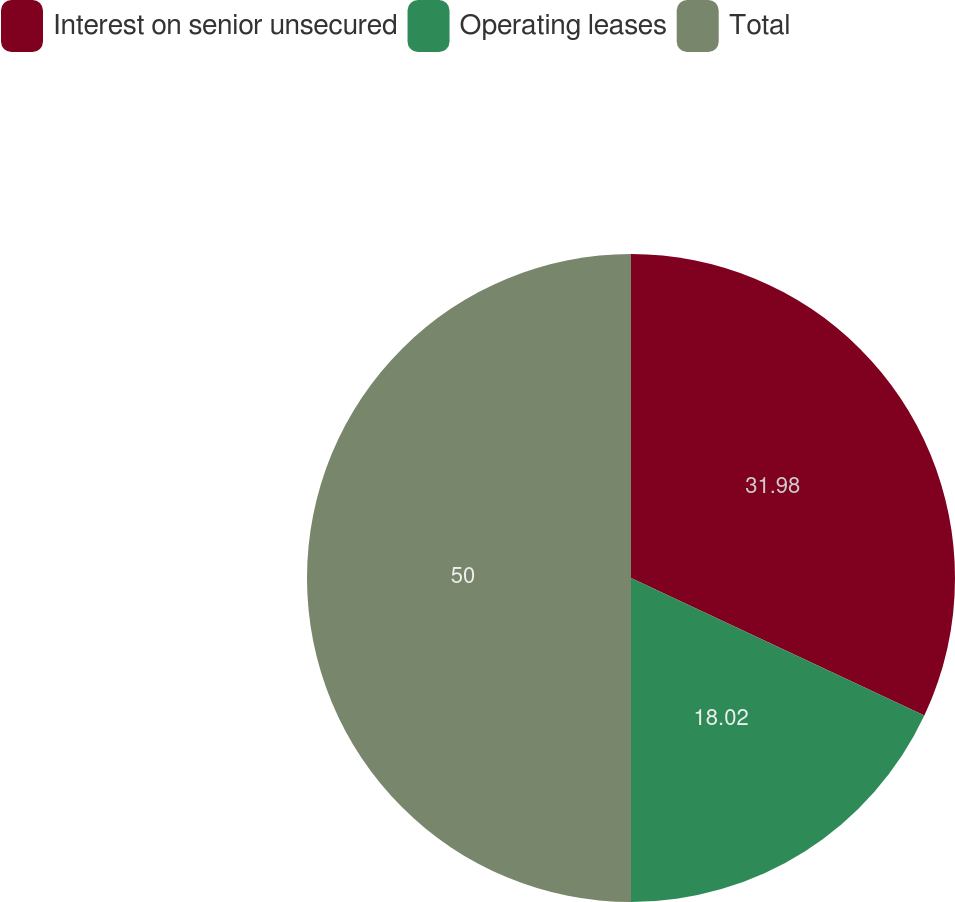Convert chart to OTSL. <chart><loc_0><loc_0><loc_500><loc_500><pie_chart><fcel>Interest on senior unsecured<fcel>Operating leases<fcel>Total<nl><fcel>31.98%<fcel>18.02%<fcel>50.0%<nl></chart> 